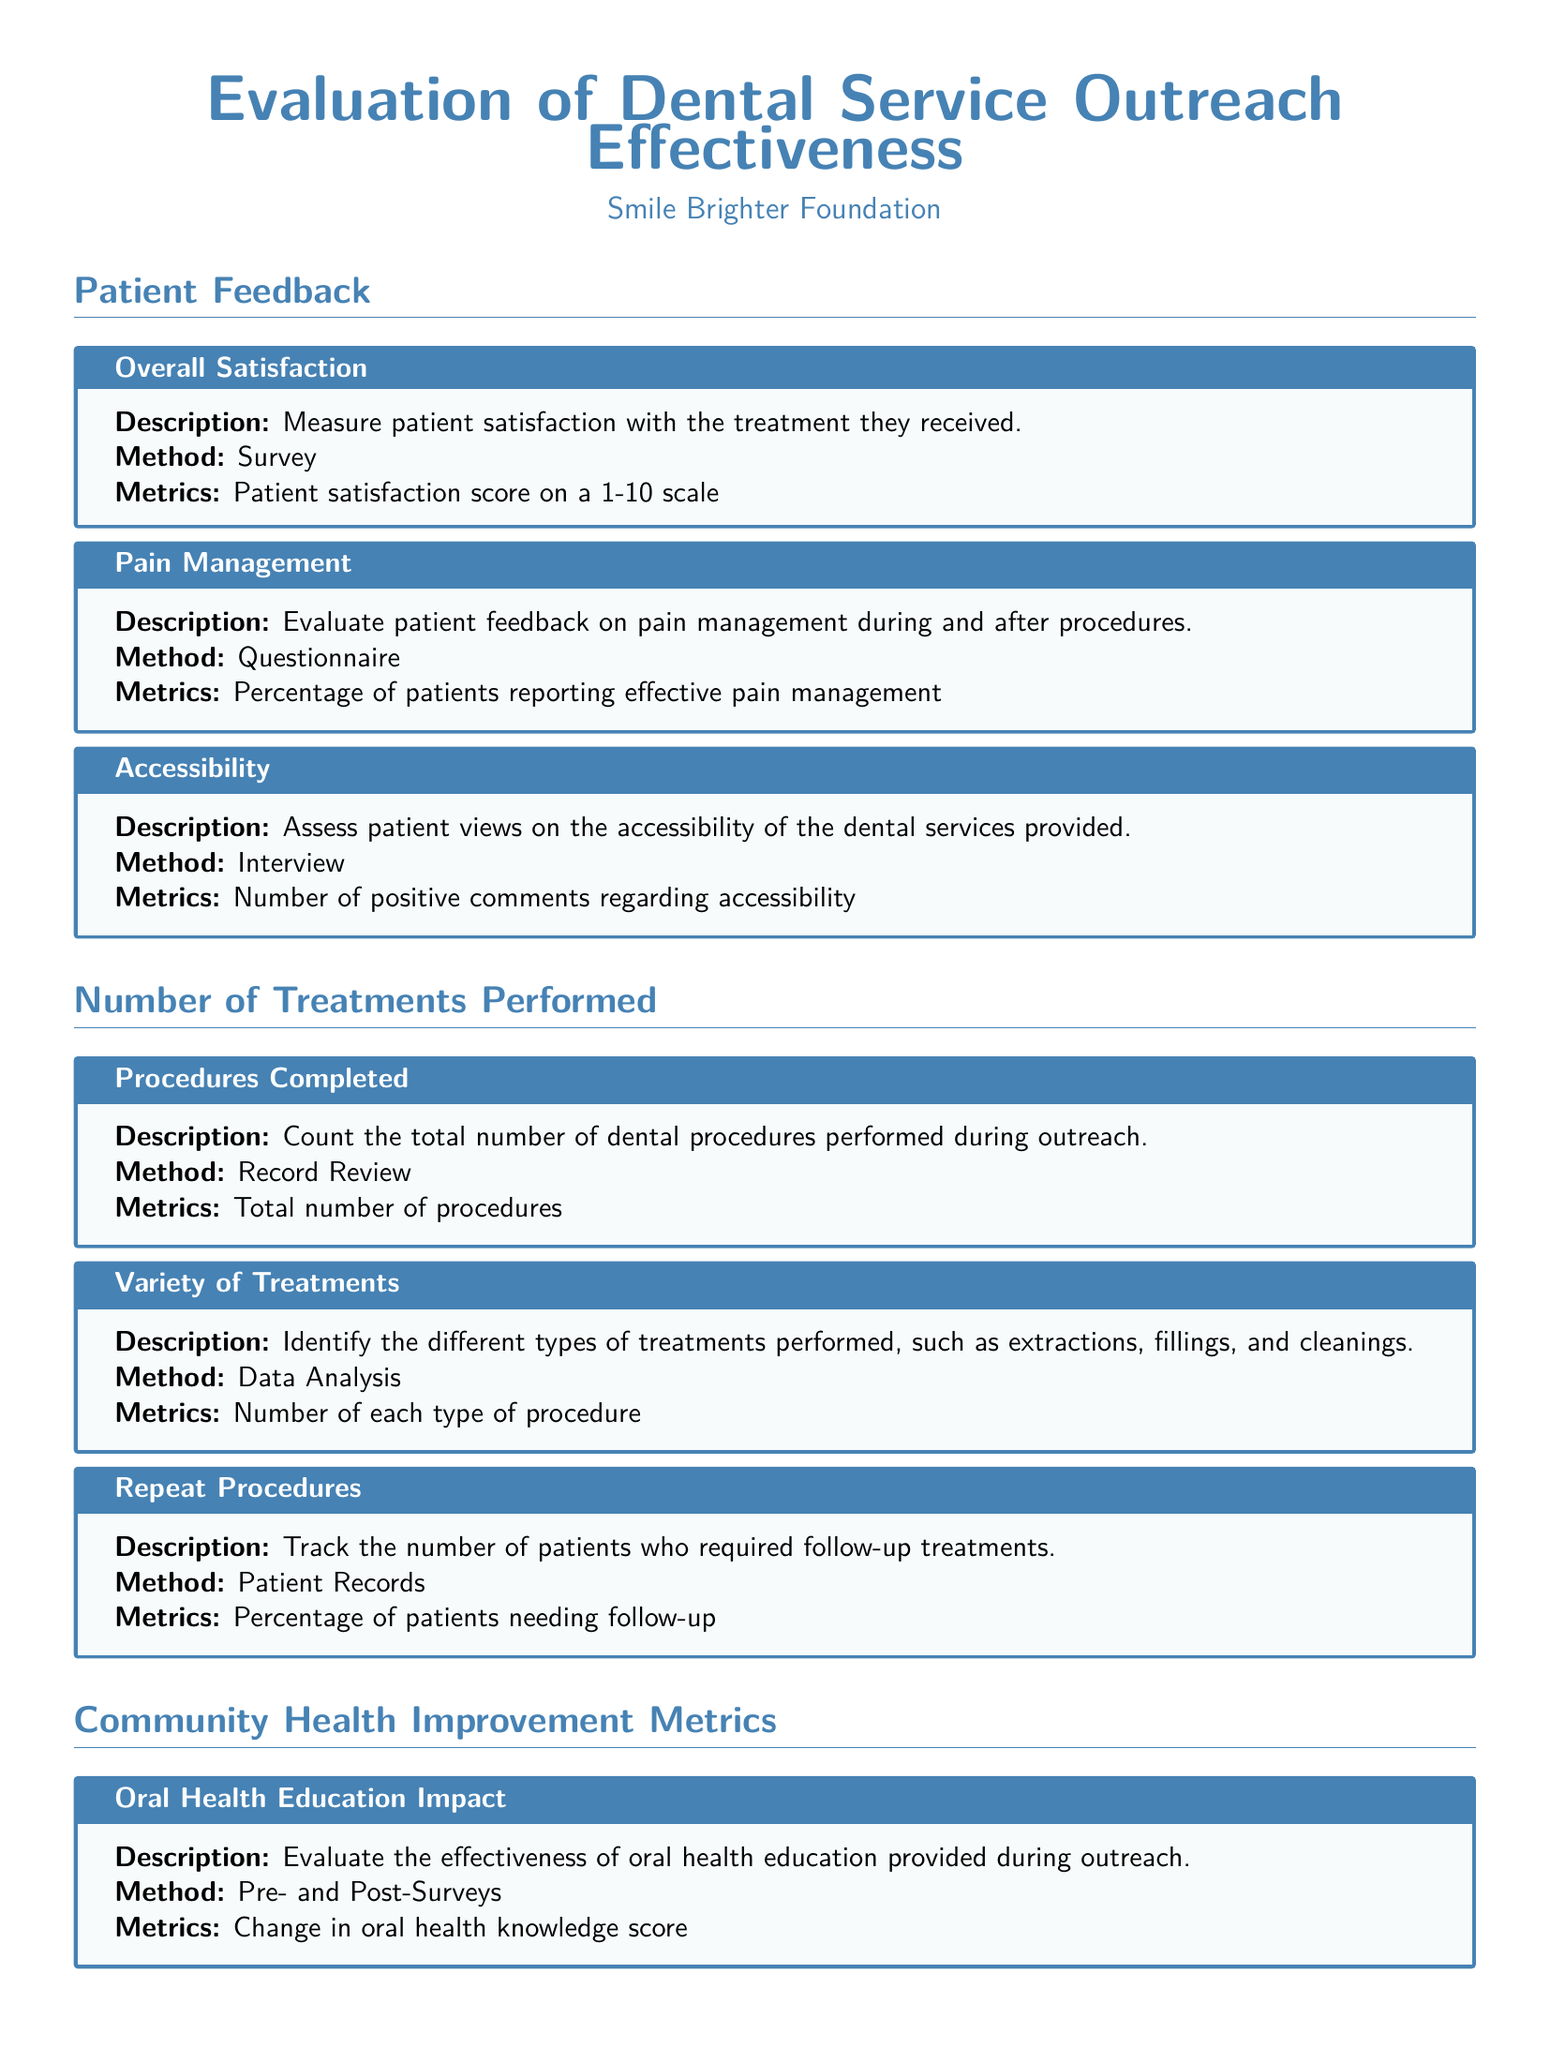What is the patient satisfaction score range? The patient satisfaction score is measured on a 1-10 scale as indicated in the document.
Answer: 1-10 What is the method used to evaluate pain management? The document states that a questionnaire is used to gather patient feedback on pain management.
Answer: Questionnaire How are the total number of dental procedures tracked? The total number of procedures is tracked through record review, as specified under the number of treatments performed.
Answer: Record Review What metrics are used to analyze community dental health statistics? The document mentions community health surveys as the method for analyzing changes in dental health statistics post-outreach.
Answer: Community Health Surveys What type of procedures are included in the variety of treatments? The document specifies treatments such as extractions, fillings, and cleanings within the variety of treatments performed.
Answer: Extractions, fillings, and cleanings What do pre- and post-surveys evaluate in the document? The effectiveness of oral health education provided during outreach is evaluated through pre- and post-surveys.
Answer: Oral health education effectiveness What percentage tracks the number of patients needing follow-up? The document states that the percentage of patients needing follow-up is the metric used for tracking repeat procedures.
Answer: Percentage of patients How is the impact of oral health education measured? Change in oral health knowledge score is used to measure the impact of oral health education as stated in the document.
Answer: Change in oral health knowledge score What is the overall focus of this appraisal form? The appraisal form focuses on evaluating the effectiveness of dental service outreach through patient feedback and community health metrics.
Answer: Effectiveness of dental service outreach 